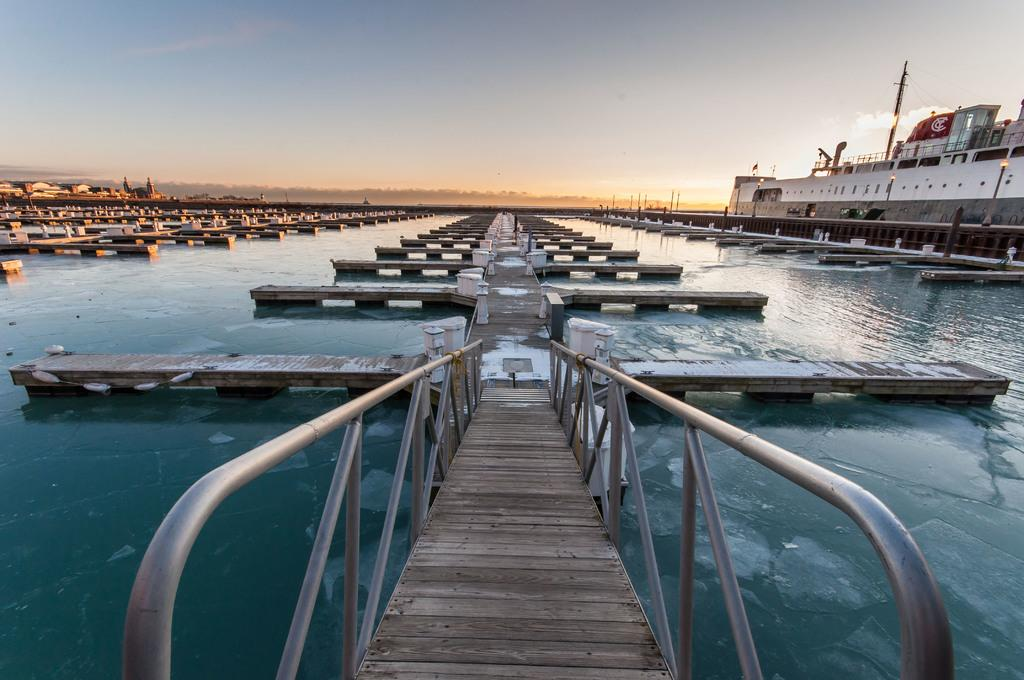What type of structure can be seen in the image? There are boat docks in the image. What is the primary body of water in the image? There is water visible in the image. What is floating on the water in the image? There is a ship floating on the right side of the image. What is visible in the background of the image? The sky is visible in the background of the image. What can be seen in the sky in the image? Clouds are present in the sky. What type of book is the ship reading in the image? There is no book or reading activity present in the image; it features a ship floating on the water. What material is the tin boat made of in the image? There is no tin boat present in the image; it features a ship made of other materials. 